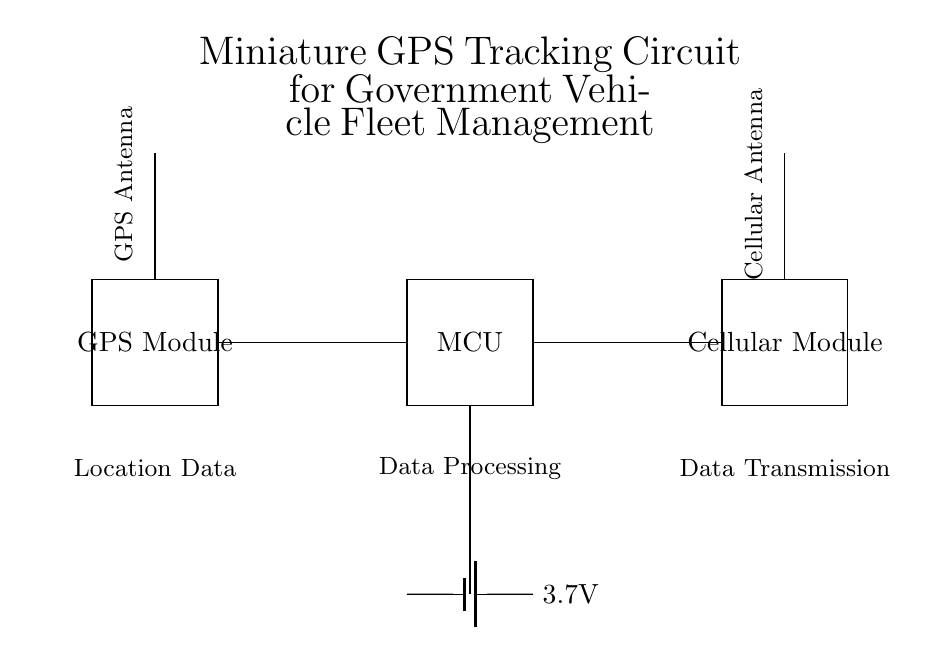What is the voltage of the power supply? The power supply section of the circuit diagram shows a battery labeled with the voltage of 3.7V. This is the voltage that the circuit components receive from the power supply.
Answer: 3.7 volts What is the function of the microcontroller? The microcontroller, depicted in the circuit, plays a key role in data processing. It takes the location data from the GPS module, processes it, and prepares it for transmission.
Answer: Data processing How many antennas are present in the circuit? The diagram includes two antennas: one for GPS and one for cellular communication. These are explicitly labeled in their respective positions in the circuit, indicating their roles.
Answer: Two antennas What components are connected to the GPS module? The GPS module has a single direct connection to the microcontroller for location data transfer, as indicated by the line connecting the two components in the circuit.
Answer: Microcontroller What type of circuit is this? This circuit is a miniature GPS tracking circuit designed specifically for government vehicle fleet management, which is indicated by the title at the top of the diagram.
Answer: Tracking circuit 